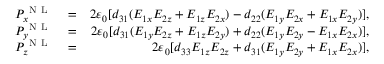Convert formula to latex. <formula><loc_0><loc_0><loc_500><loc_500>\begin{array} { r l r } { P _ { x } ^ { N L } } & = } & { 2 \varepsilon _ { 0 } [ d _ { 3 1 } ( E _ { 1 x } E _ { 2 z } + E _ { 1 z } E _ { 2 x } ) - d _ { 2 2 } ( E _ { 1 y } E _ { 2 x } + E _ { 1 x } E _ { 2 y } ) ] , } \\ { P _ { y } ^ { N L } } & = } & { 2 \varepsilon _ { 0 } [ d _ { 3 1 } ( E _ { 1 y } E _ { 2 z } + E _ { 1 z } E _ { 2 y } ) + d _ { 2 2 } ( E _ { 1 y } E _ { 2 y } - E _ { 1 x } E _ { 2 x } ) ] , } \\ { P _ { z } ^ { N L } } & = } & { 2 \varepsilon _ { 0 } [ d _ { 3 3 } E _ { 1 z } E _ { 2 z } + d _ { 3 1 } ( E _ { 1 y } E _ { 2 y } + E _ { 1 x } E _ { 2 x } ) ] , } \end{array}</formula> 